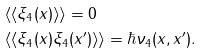Convert formula to latex. <formula><loc_0><loc_0><loc_500><loc_500>& \langle \langle \xi _ { 4 } ( x ) \rangle \rangle = 0 \\ & \langle \langle \xi _ { 4 } ( x ) \xi _ { 4 } ( x ^ { \prime } ) \rangle \rangle = \hbar { \nu } _ { 4 } ( x , x ^ { \prime } ) .</formula> 